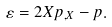Convert formula to latex. <formula><loc_0><loc_0><loc_500><loc_500>\varepsilon = 2 X p _ { , X } - p .</formula> 